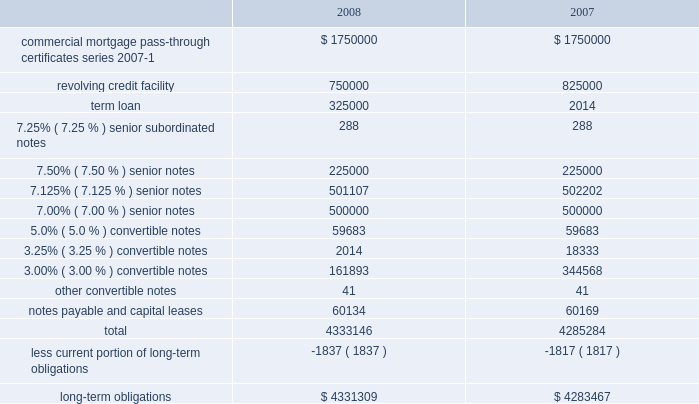American tower corporation and subsidiaries notes to consolidated financial statements 2014 ( continued ) 6 .
Long-term obligations outstanding amounts under the company 2019s long-term financing arrangements consist of the following as of december 31 , ( in thousands ) : .
Commercial mortgage pass-through certificates , series 2007-1 2014during the year ended december 31 , 2007 , the company completed a securitization transaction ( the securitization ) involving assets related to 5295 broadcast and wireless communications towers ( the secured towers ) owned by two special purpose subsidiaries of the company , through a private offering of $ 1.75 billion of commercial mortgage pass-through certificates , series 2007-1 ( the certificates ) .
The certificates were issued by american tower trust i ( the trust ) , a trust established by american tower depositor sub , llc ( the depositor ) , an indirect wholly owned special purpose subsidiary of the company .
The assets of the trust consist of a recourse loan ( the loan ) initially made by the depositor to american tower asset sub , llc and american tower asset sub ii , llc ( the borrowers ) , pursuant to a loan and security agreement among the foregoing parties dated as of may 4 , 2007 ( the loan agreement ) .
The borrowers are special purpose entities formed solely for the purpose of holding the secured towers subject to the securitization .
The certificates were issued in seven separate classes , comprised of class a-fx , class a-fl , class b , class c , class d , class e and class f .
Each of the certificates in classes b , c , d , e and f are subordinated in right of payment to any other class of certificates which has an earlier alphabetical designation .
The certificates were issued with terms identical to the loan except for the class a-fl certificates , which bear interest at a floating rate while the related component of the loan bears interest at a fixed rate , as described below .
The various classes of certificates were issued with a weighted average interest rate of approximately 5.61% ( 5.61 % ) .
The certificates have an expected life of approximately seven years with a final repayment date in april 2037 .
The company used the net proceeds from the securitization to repay all amounts outstanding under the spectrasite credit facilities , including approximately $ 765.0 million in principal , plus accrued interest thereon and other costs and expenses related thereto , as well as to repay approximately $ 250.0 million drawn under the revolving loan component of the credit facilities at the american tower operating company level .
An additional $ 349.5 million of the proceeds was used to fund the company 2019s tender offer and consent solicitation for the ati .
What was the change in thousands in total outstandings under long term financing arrangements from 2007 to 2008? 
Computations: (4333146 - 4285284)
Answer: 47862.0. 